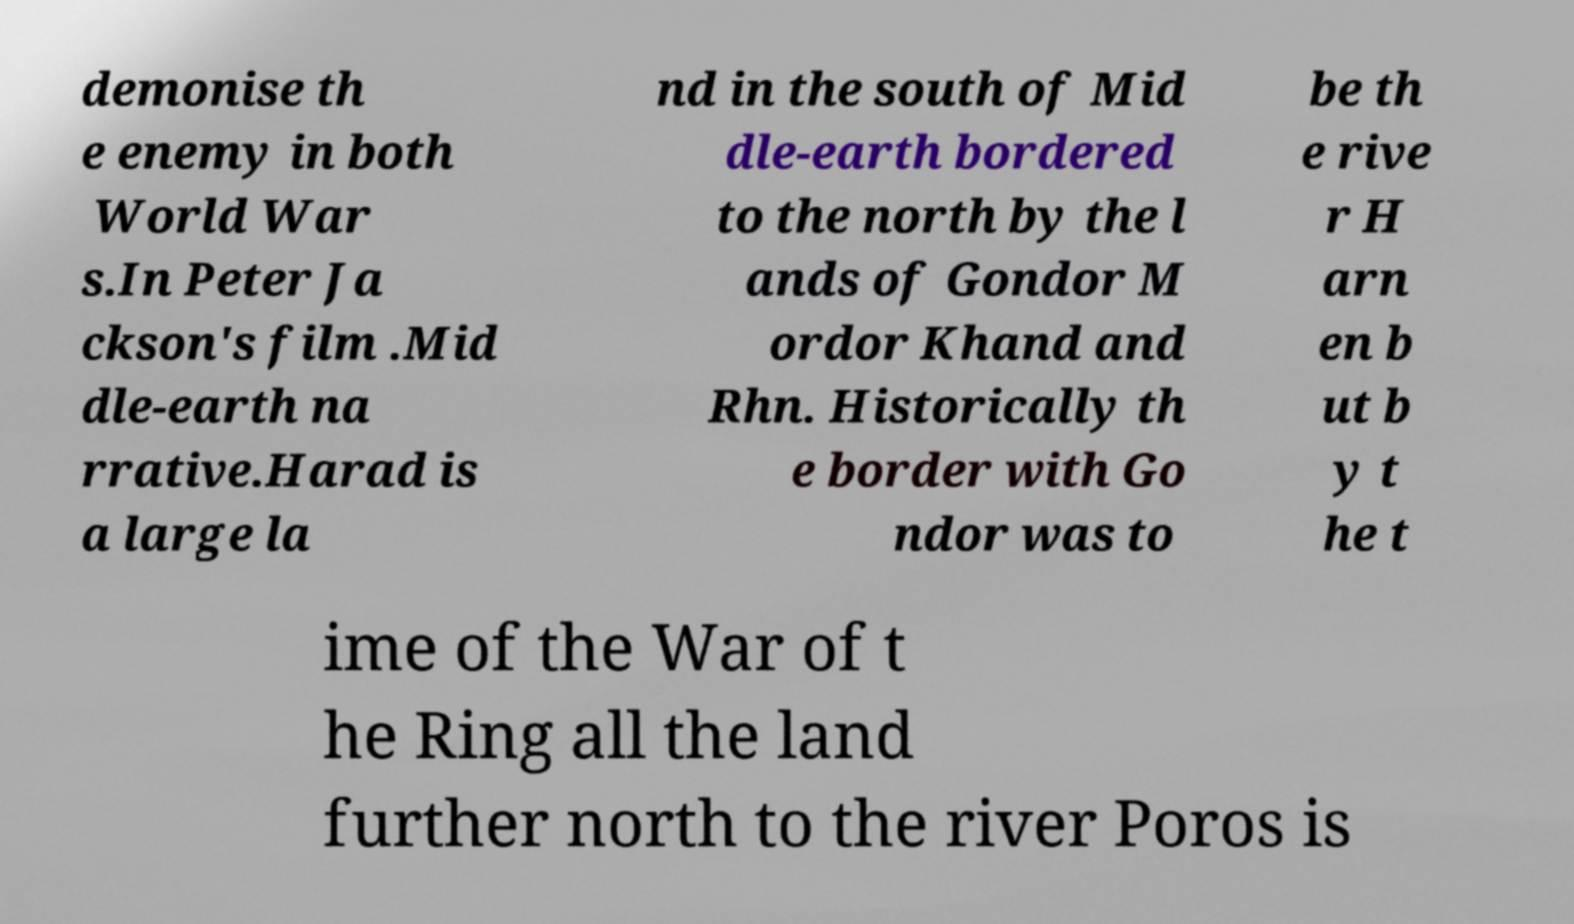Could you extract and type out the text from this image? demonise th e enemy in both World War s.In Peter Ja ckson's film .Mid dle-earth na rrative.Harad is a large la nd in the south of Mid dle-earth bordered to the north by the l ands of Gondor M ordor Khand and Rhn. Historically th e border with Go ndor was to be th e rive r H arn en b ut b y t he t ime of the War of t he Ring all the land further north to the river Poros is 